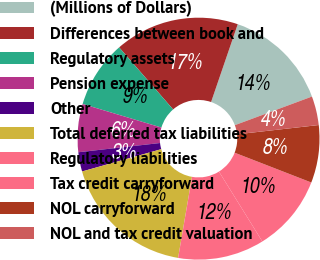Convert chart. <chart><loc_0><loc_0><loc_500><loc_500><pie_chart><fcel>(Millions of Dollars)<fcel>Differences between book and<fcel>Regulatory assets<fcel>Pension expense<fcel>Other<fcel>Total deferred tax liabilities<fcel>Regulatory liabilities<fcel>Tax credit carryforward<fcel>NOL carryforward<fcel>NOL and tax credit valuation<nl><fcel>14.09%<fcel>16.65%<fcel>8.98%<fcel>6.42%<fcel>2.58%<fcel>17.93%<fcel>11.54%<fcel>10.26%<fcel>7.7%<fcel>3.86%<nl></chart> 